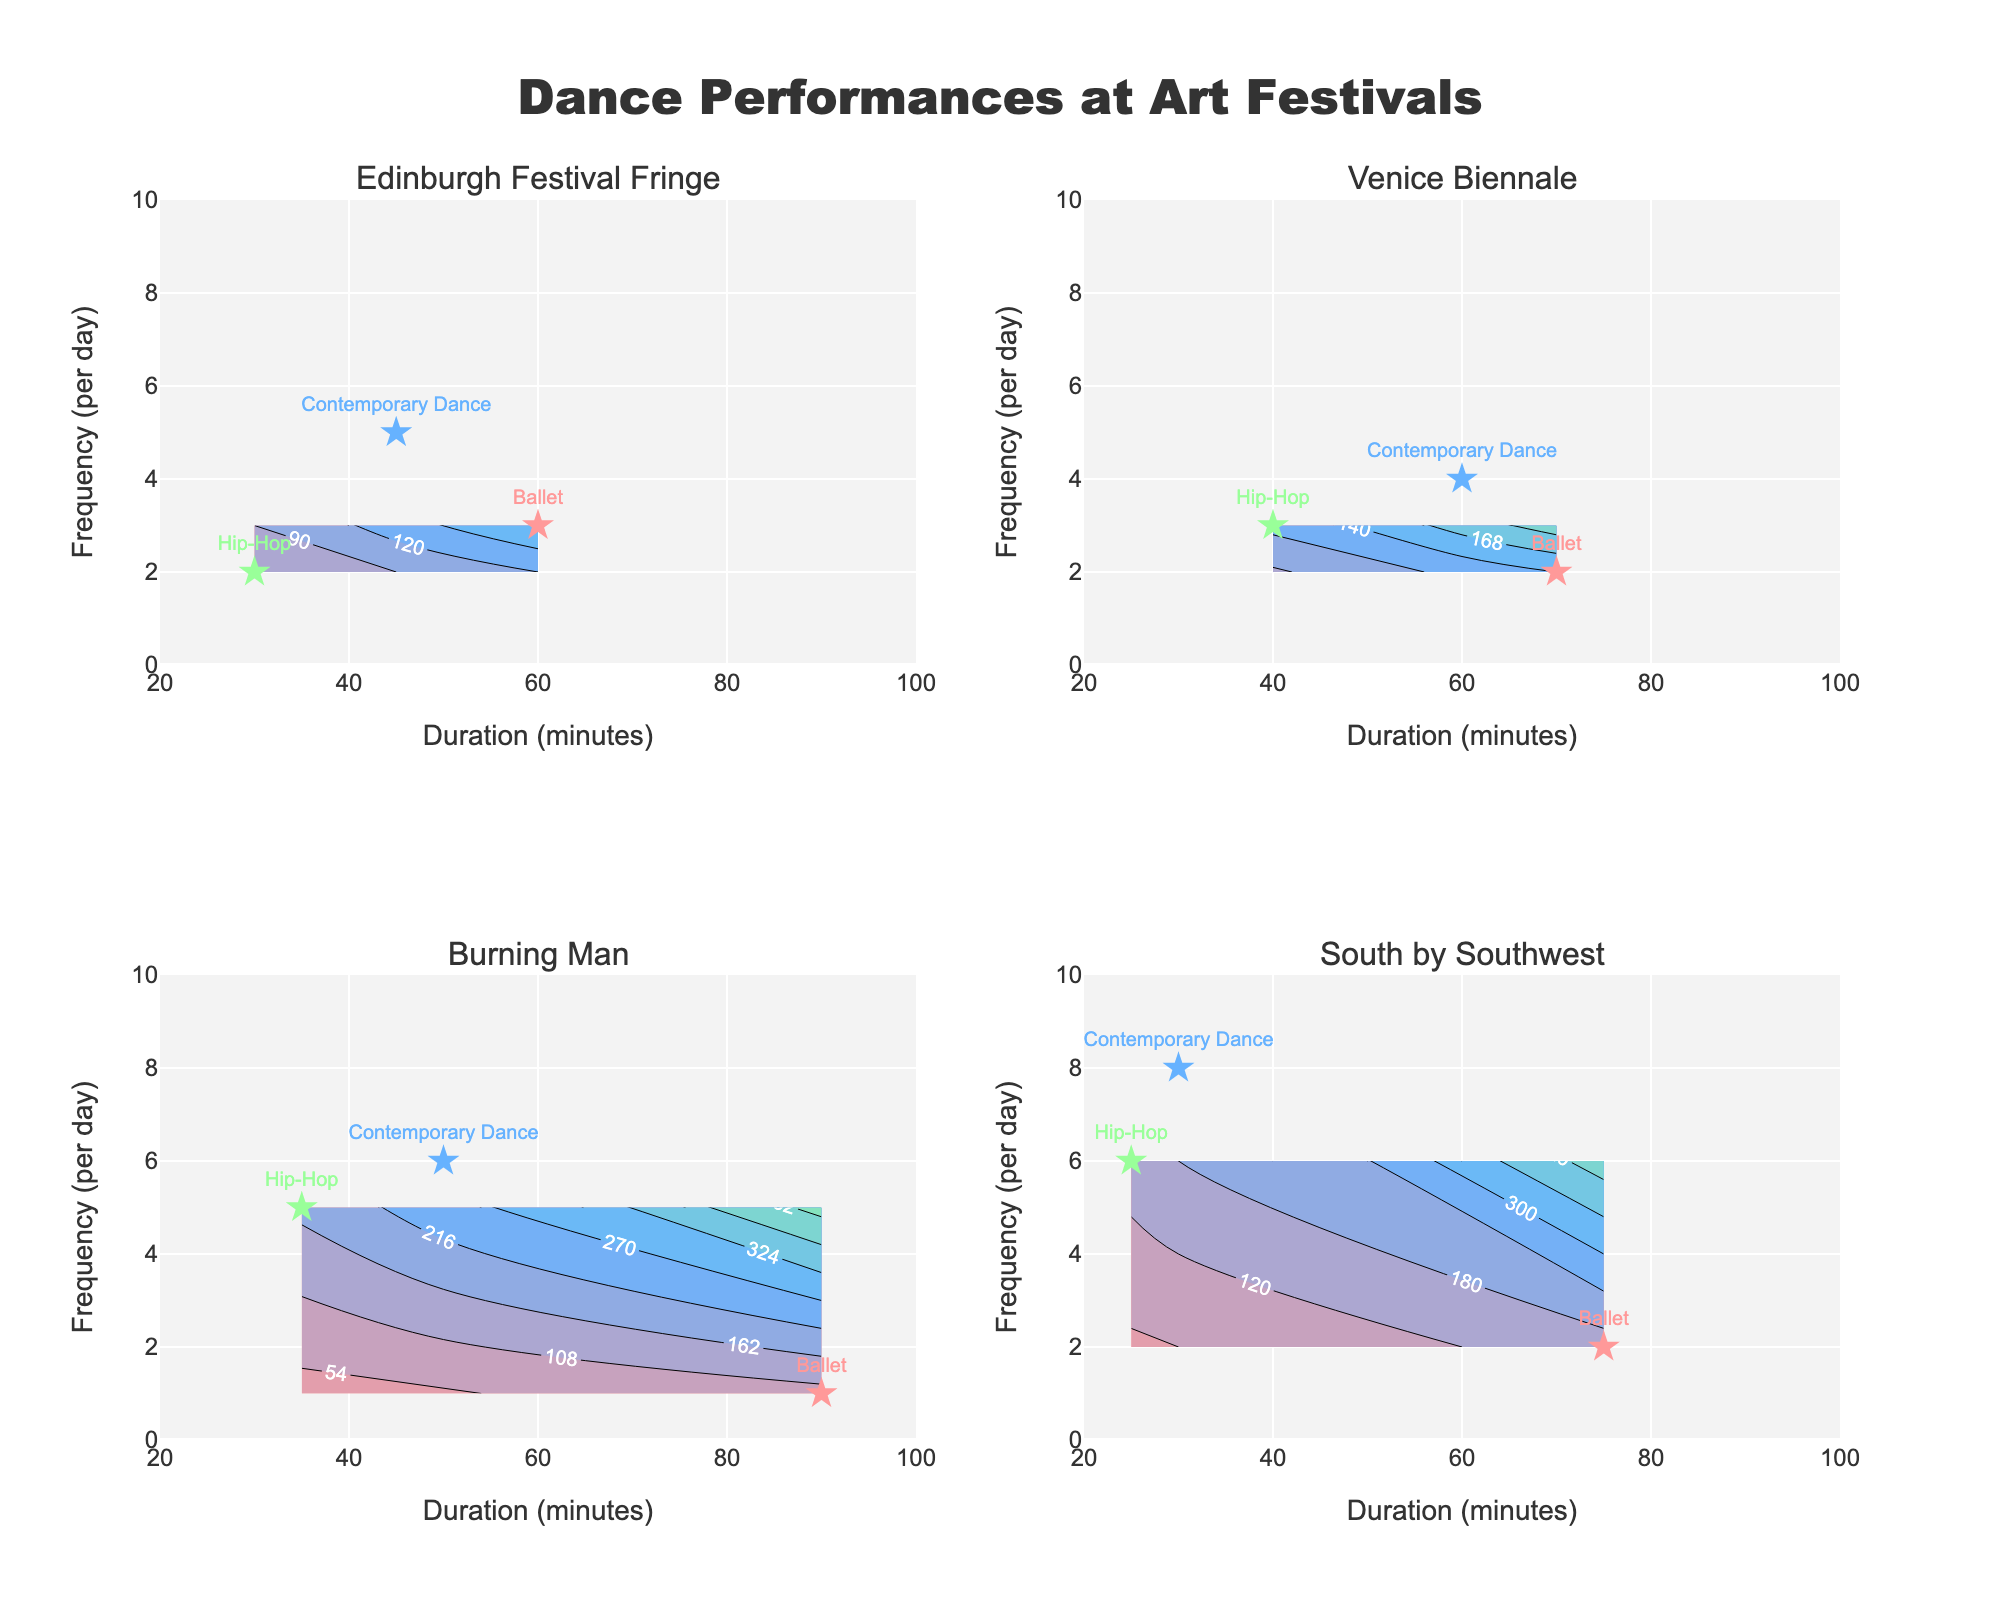What's the title of the figure? The title of the figure is prominently displayed at the top center of the plot. It reads "Dance Performances at Art Festivals."
Answer: Dance Performances at Art Festivals What are the labels for the x and y axes? The labels for the x and y axes are found directly on the axes themselves. The x-axis is labeled "Duration (minutes)," and the y-axis is labeled "Frequency (per day)."
Answer: Duration (minutes) and Frequency (per day) Which festival features the most frequent Contemporary Dance performances? By observing the text labels associated with Contemporary Dance points and their position along the y-axis, South by Southwest has the highest frequency, showing 8 performances per day for Contemporary Dance.
Answer: South by Southwest How does the frequency of Ballet performances at the Edinburgh Festival Fringe compare to that at Burning Man? Looking at the Ballet marker points for both festivals, Edinburgh Festival Fringe has 3 Ballet performances per day while Burning Man has only 1. Thus, Edinburgh Festival Fringe has more frequent Ballet performances than Burning Man.
Answer: More frequent at Edinburgh Festival Fringe Which performance has the longest duration at Venice Biennale? By examining the x-axis positions of the performance markers at Venice Biennale, the Ballet marker is farthest to the right, indicating the longest duration of 70 minutes.
Answer: Ballet For which festival does Ballet have the shortest duration? Looking at the Ballet markers across different festivals and their x-axis positions, Burning Man features the shortest Ballet duration of 90 minutes.
Answer: Burning Man Compare the frequency of Hip-Hop performances at South by Southwest to Edinburgh Festival Fringe. Observing the y-axis positions of Hip-Hop performance markers, South by Southwest shows 6 performances per day while Edinburgh Festival Fringe shows 2 performances per day. Therefore, South by Southwest has a higher frequency.
Answer: Higher at South by Southwest What is the average duration of Contemporary Dance performances across all festivals? By summing the durations of Contemporary Dance for all festivals (45 + 60 + 50 + 30) and then dividing by the number of festivals (4): (45 + 60 + 50 + 30) / 4 = 185 / 4 = 46.25
Answer: 46.25 minutes Which festival has the highest variety (different types) of performances? Since all festivals have Ballet, Contemporary Dance, and Hip-Hop performances shown by three distinct symbols and text labels in each subplot, they all have an equal variety of three different performances.
Answer: Same for all festivals What is the color used to represent the Hip-Hop performance markers? Observing the scatter plot points closely, the color used for Hip-Hop markers is consistent across all subplots. It is a consistent greenish hue.
Answer: Green 